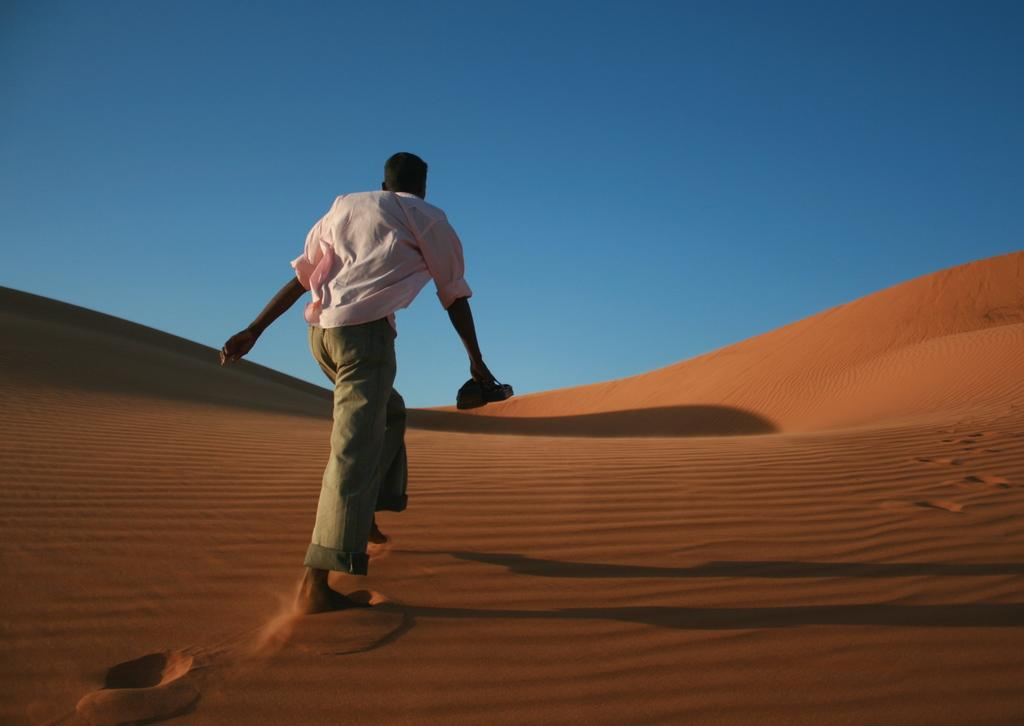What is the main subject of the image? There is a person standing in the image. Where is the person standing? The person is standing in a desert. What can be seen in the background of the image? The sky is visible in the background of the image. What type of meat can be seen being cooked on a stage in the image? There is no meat or stage present in the image; it features a person standing in a desert. 